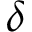Convert formula to latex. <formula><loc_0><loc_0><loc_500><loc_500>\delta</formula> 